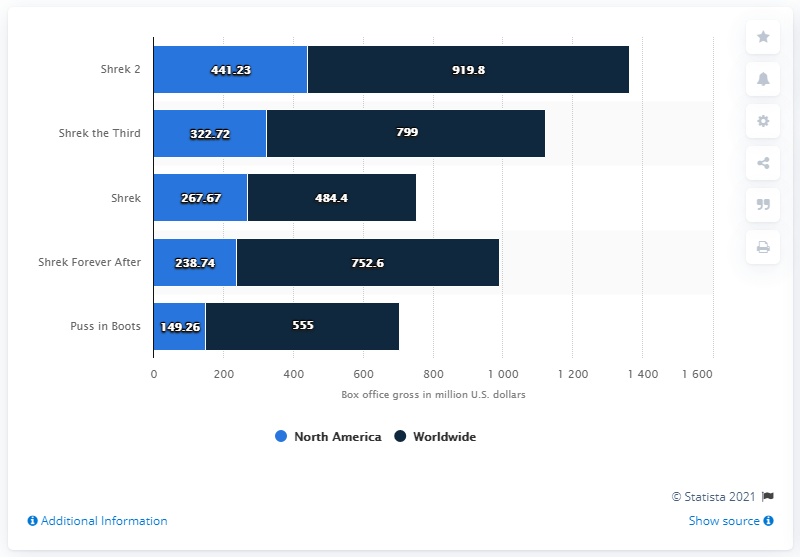Highlight a few significant elements in this photo. The gross of Shrek Forever After was 238.74. The average of the box office revenue of Shrek and Shrek 2 in North America is 354.45. The worldwide box office revenue of Puss in Boots was approximately $555 million in the United States dollars. 